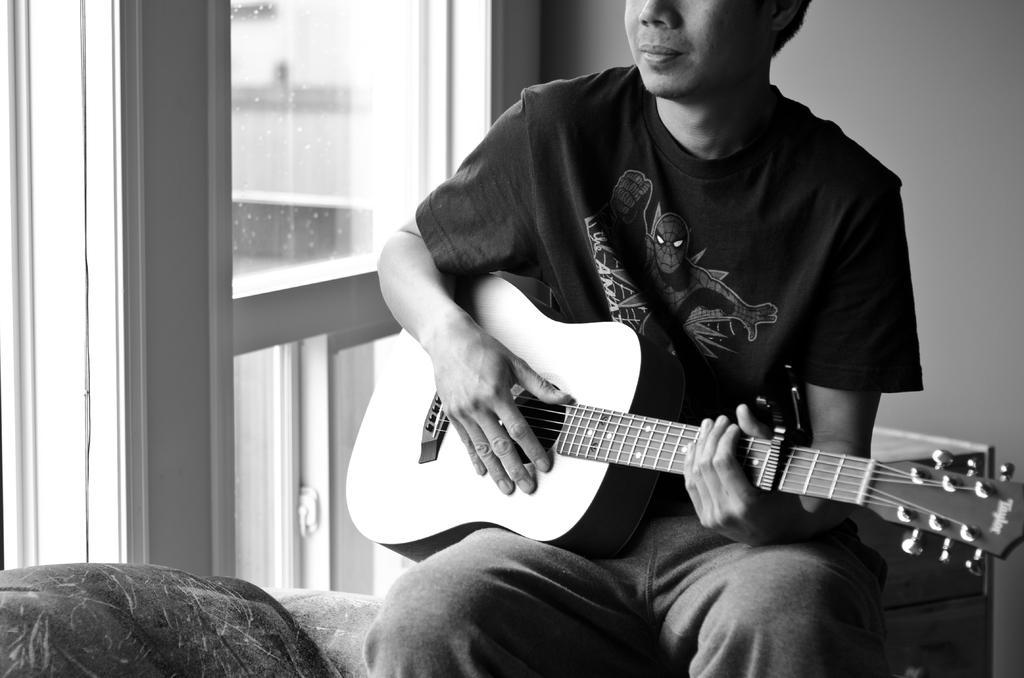Please provide a concise description of this image. This is black & white picture. Here we can see a man sitting and playing guitar. This is a wall. 